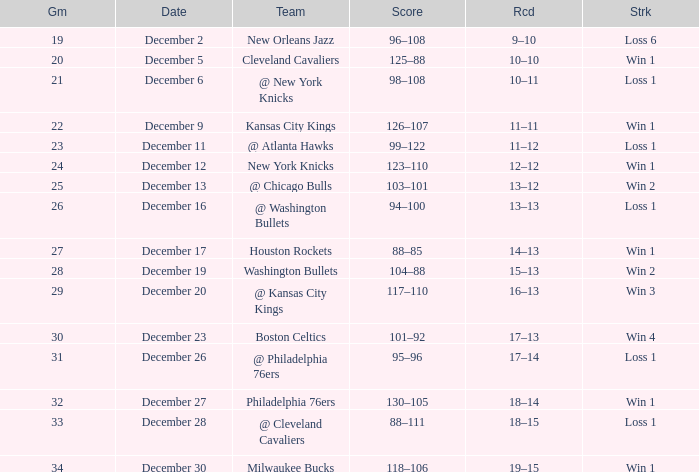What is the Score of the Game with a Record of 13–12? 103–101. 